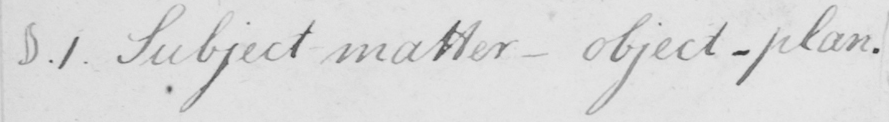What is written in this line of handwriting? §.1 . Subject matter  _   object-plan . 